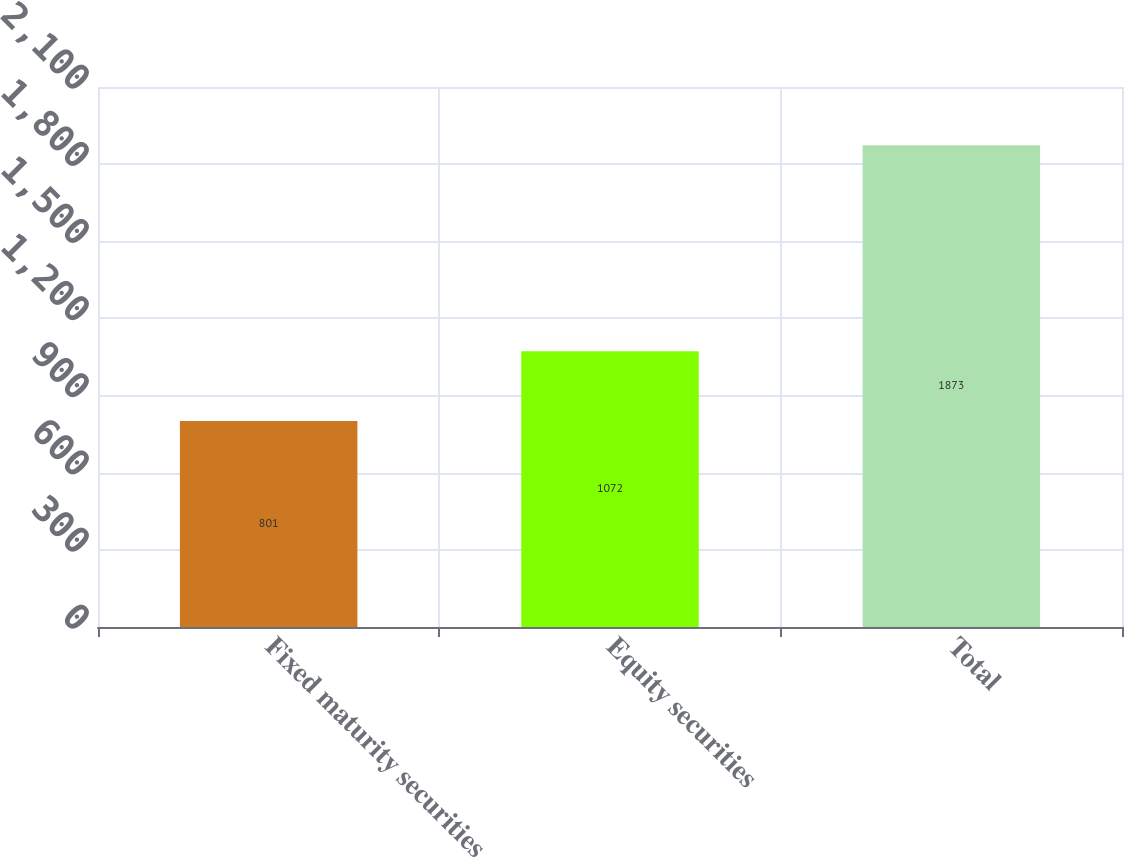Convert chart to OTSL. <chart><loc_0><loc_0><loc_500><loc_500><bar_chart><fcel>Fixed maturity securities<fcel>Equity securities<fcel>Total<nl><fcel>801<fcel>1072<fcel>1873<nl></chart> 